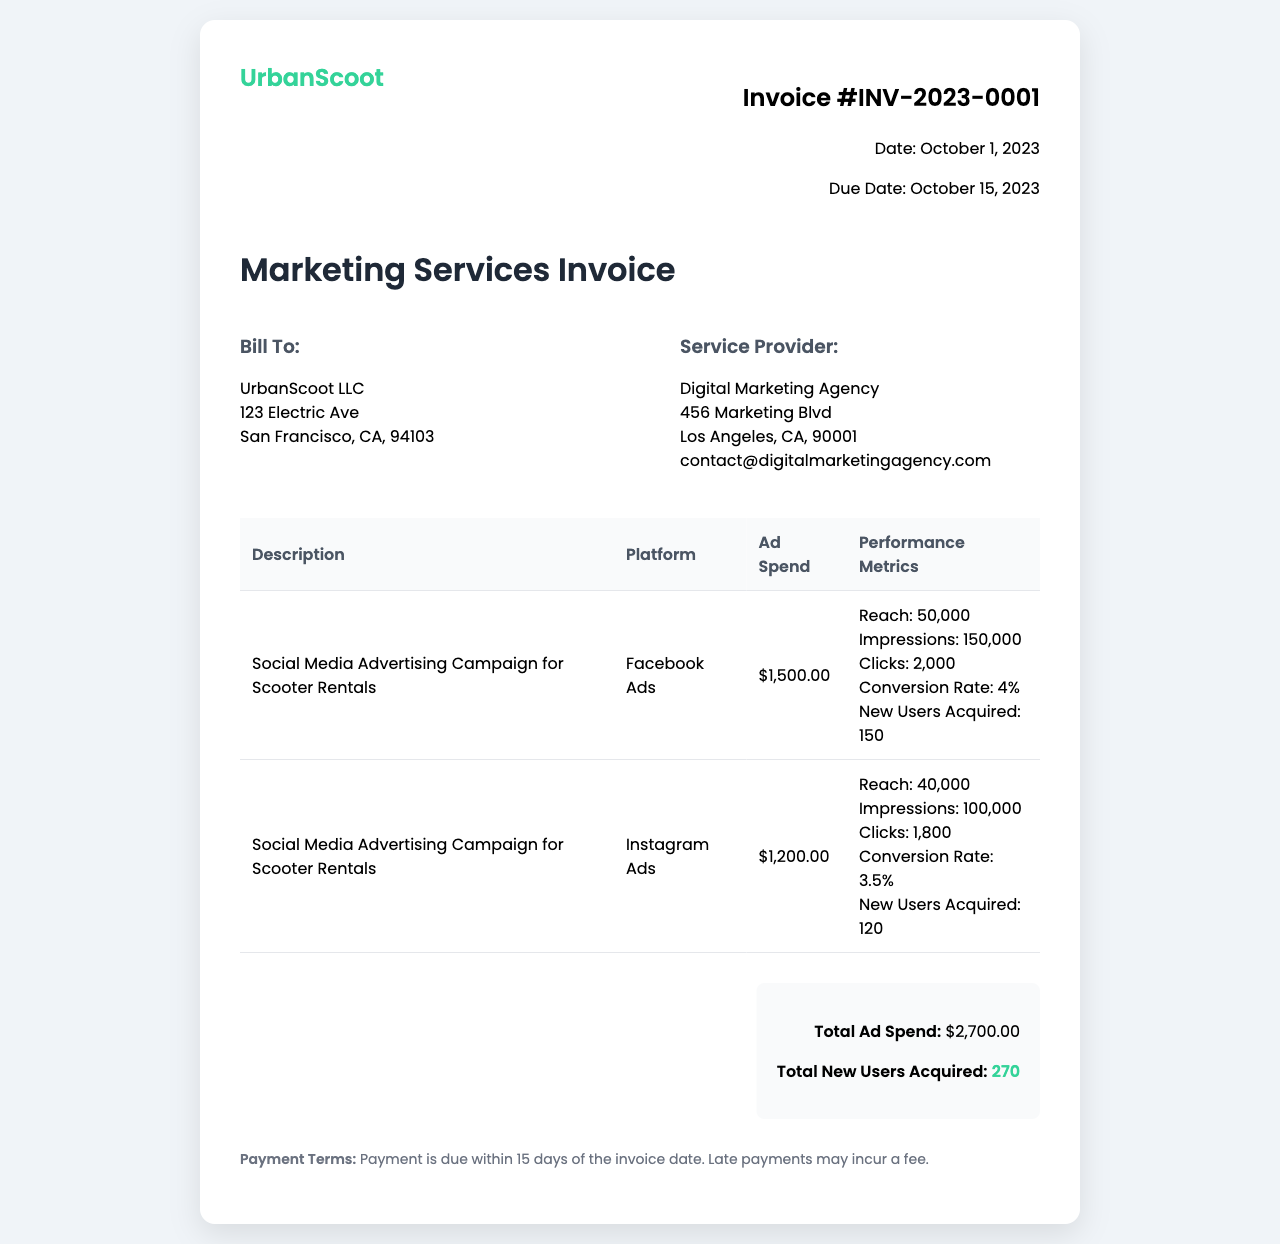What is the invoice number? The invoice number is specified in the document as "INV-2023-0001".
Answer: INV-2023-0001 What is the due date for the invoice? The due date is provided in the invoice details, which states "October 15, 2023".
Answer: October 15, 2023 What is the total ad spend? The total ad spend is calculated and displayed in the summary section as "$2,700.00".
Answer: $2,700.00 Which platform had the highest ad spend? By comparing the ad spends for each platform, Facebook Ads has the highest spend of "$1,500.00".
Answer: Facebook Ads What is the conversion rate for Instagram Ads? The conversion rate for Instagram Ads is shown in the performance metrics as "3.5%".
Answer: 3.5% How many total new users were acquired from the campaigns? The total number of new users acquired from both campaigns is summarized as "270".
Answer: 270 Who is the service provider? The service provider is listed as "Digital Marketing Agency".
Answer: Digital Marketing Agency What type of service is being billed? The description specifies that the service is for "Marketing Services".
Answer: Marketing Services What is the payment term for this invoice? The payment terms state that payment is due "within 15 days of the invoice date".
Answer: within 15 days of the invoice date 